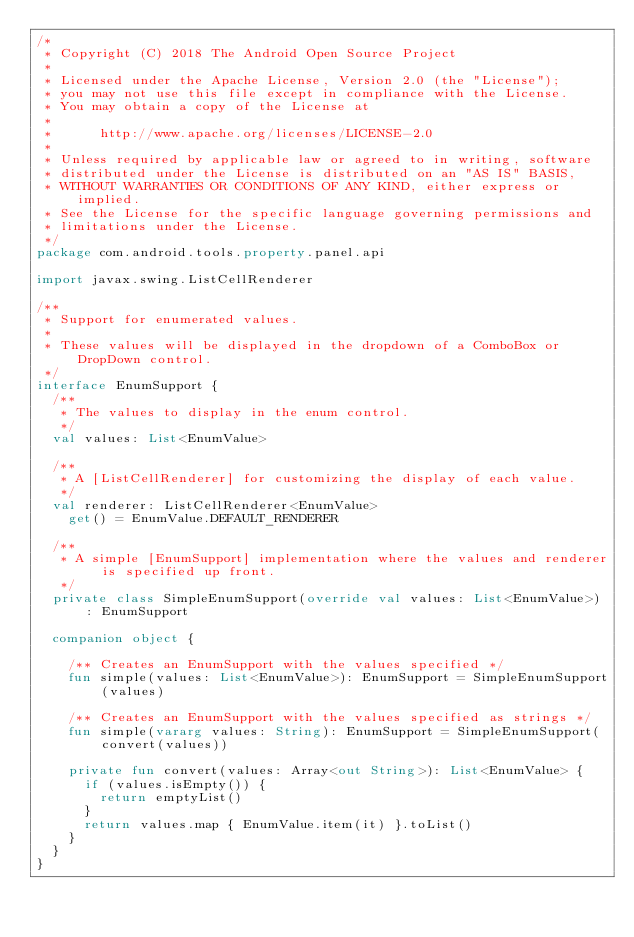Convert code to text. <code><loc_0><loc_0><loc_500><loc_500><_Kotlin_>/*
 * Copyright (C) 2018 The Android Open Source Project
 *
 * Licensed under the Apache License, Version 2.0 (the "License");
 * you may not use this file except in compliance with the License.
 * You may obtain a copy of the License at
 *
 *      http://www.apache.org/licenses/LICENSE-2.0
 *
 * Unless required by applicable law or agreed to in writing, software
 * distributed under the License is distributed on an "AS IS" BASIS,
 * WITHOUT WARRANTIES OR CONDITIONS OF ANY KIND, either express or implied.
 * See the License for the specific language governing permissions and
 * limitations under the License.
 */
package com.android.tools.property.panel.api

import javax.swing.ListCellRenderer

/**
 * Support for enumerated values.
 *
 * These values will be displayed in the dropdown of a ComboBox or DropDown control.
 */
interface EnumSupport {
  /**
   * The values to display in the enum control.
   */
  val values: List<EnumValue>

  /**
   * A [ListCellRenderer] for customizing the display of each value.
   */
  val renderer: ListCellRenderer<EnumValue>
    get() = EnumValue.DEFAULT_RENDERER

  /**
   * A simple [EnumSupport] implementation where the values and renderer is specified up front.
   */
  private class SimpleEnumSupport(override val values: List<EnumValue>) : EnumSupport

  companion object {

    /** Creates an EnumSupport with the values specified */
    fun simple(values: List<EnumValue>): EnumSupport = SimpleEnumSupport(values)

    /** Creates an EnumSupport with the values specified as strings */
    fun simple(vararg values: String): EnumSupport = SimpleEnumSupport(convert(values))

    private fun convert(values: Array<out String>): List<EnumValue> {
      if (values.isEmpty()) {
        return emptyList()
      }
      return values.map { EnumValue.item(it) }.toList()
    }
  }
}
</code> 